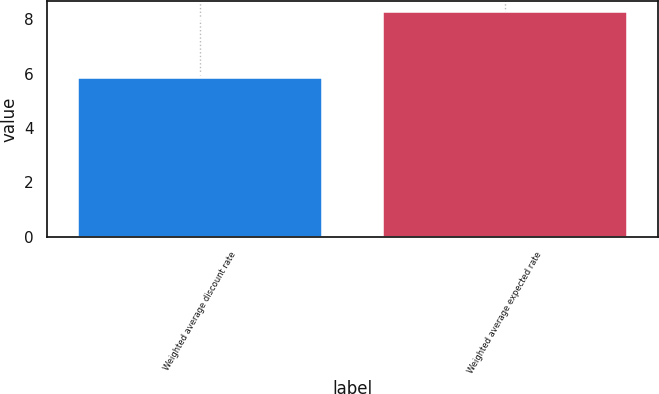<chart> <loc_0><loc_0><loc_500><loc_500><bar_chart><fcel>Weighted average discount rate<fcel>Weighted average expected rate<nl><fcel>5.82<fcel>8.25<nl></chart> 